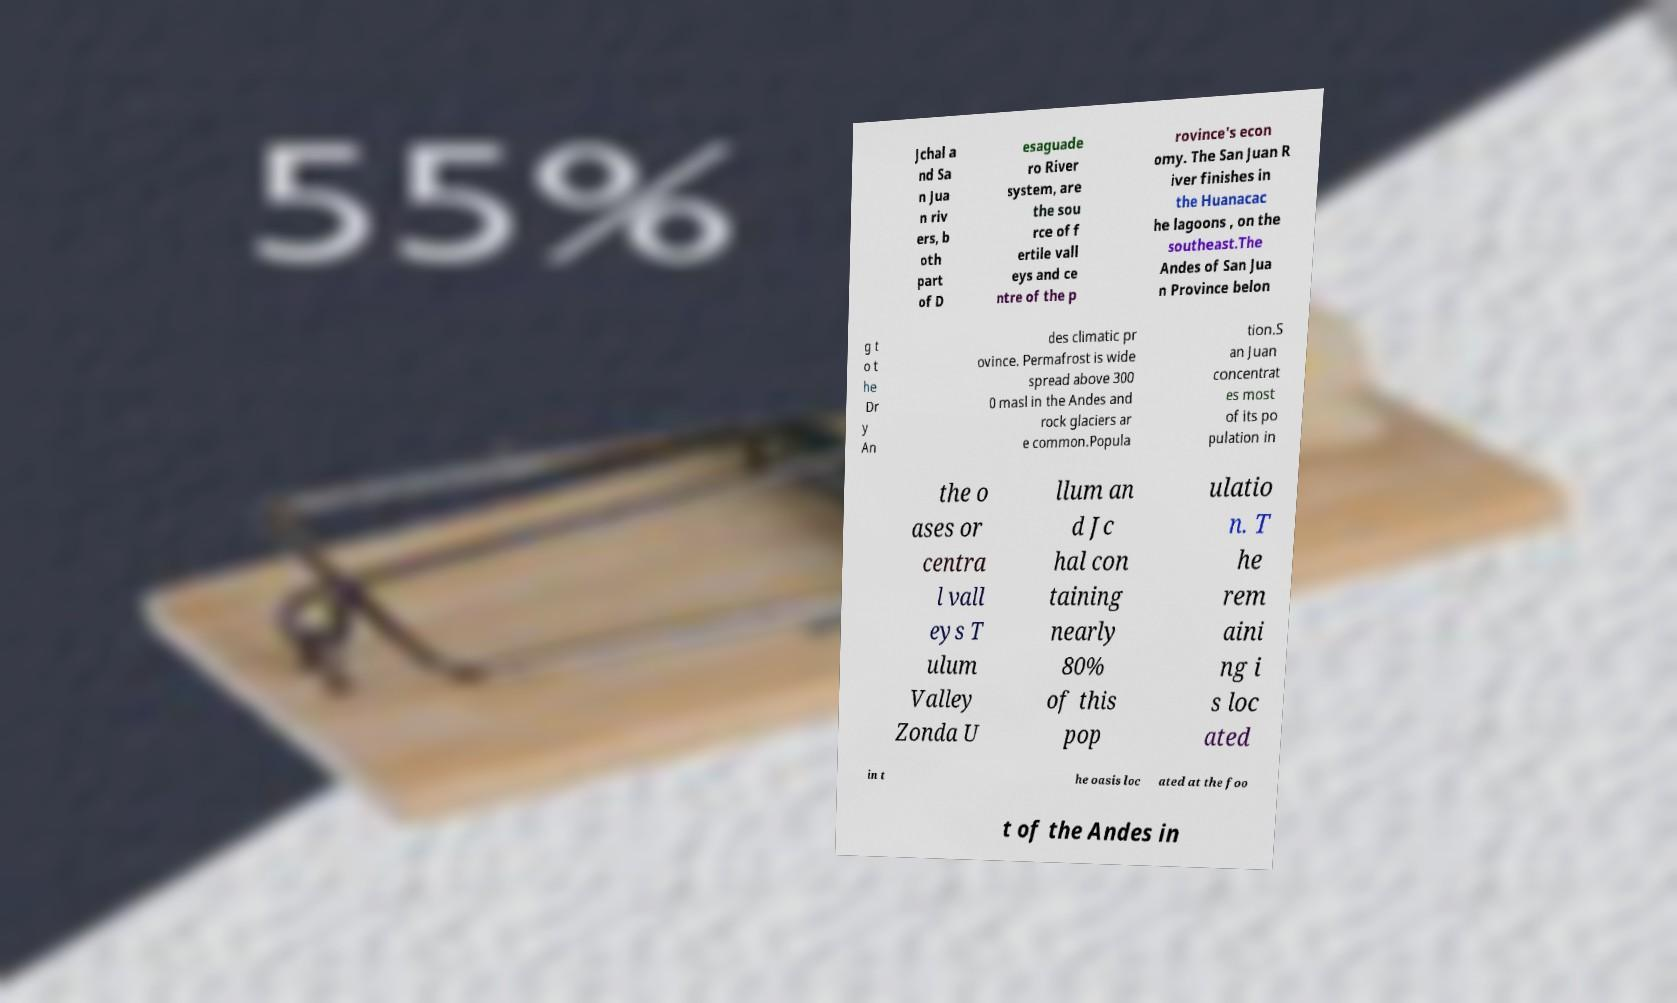What messages or text are displayed in this image? I need them in a readable, typed format. Jchal a nd Sa n Jua n riv ers, b oth part of D esaguade ro River system, are the sou rce of f ertile vall eys and ce ntre of the p rovince's econ omy. The San Juan R iver finishes in the Huanacac he lagoons , on the southeast.The Andes of San Jua n Province belon g t o t he Dr y An des climatic pr ovince. Permafrost is wide spread above 300 0 masl in the Andes and rock glaciers ar e common.Popula tion.S an Juan concentrat es most of its po pulation in the o ases or centra l vall eys T ulum Valley Zonda U llum an d Jc hal con taining nearly 80% of this pop ulatio n. T he rem aini ng i s loc ated in t he oasis loc ated at the foo t of the Andes in 